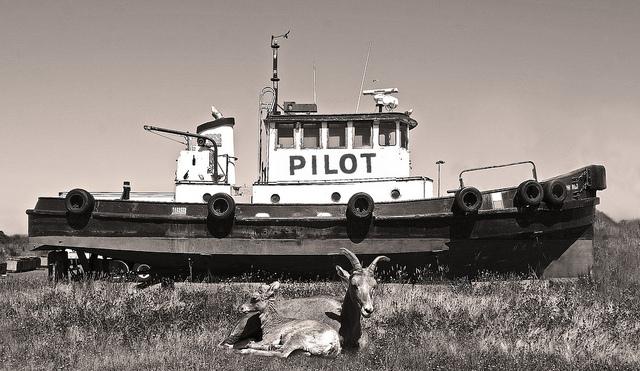Is the boat on water or grass?
Short answer required. Grass. What is the word on the boat?
Answer briefly. Pilot. What is laying in front of the boat?
Keep it brief. Goat. 